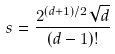Convert formula to latex. <formula><loc_0><loc_0><loc_500><loc_500>s = \frac { 2 ^ { ( d + 1 ) / 2 } \sqrt { d } } { ( d - 1 ) ! }</formula> 